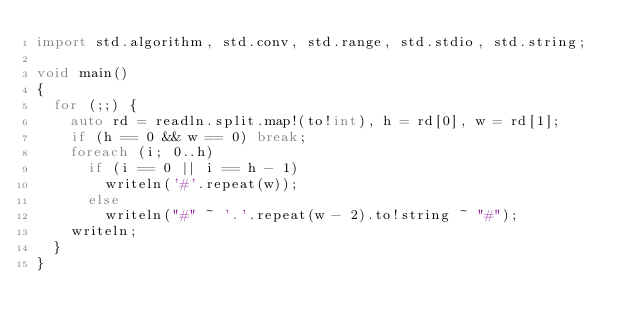<code> <loc_0><loc_0><loc_500><loc_500><_D_>import std.algorithm, std.conv, std.range, std.stdio, std.string;

void main()
{
  for (;;) {
    auto rd = readln.split.map!(to!int), h = rd[0], w = rd[1];
    if (h == 0 && w == 0) break;
    foreach (i; 0..h)
      if (i == 0 || i == h - 1)
        writeln('#'.repeat(w));
      else
        writeln("#" ~ '.'.repeat(w - 2).to!string ~ "#");
    writeln;
  }
}</code> 